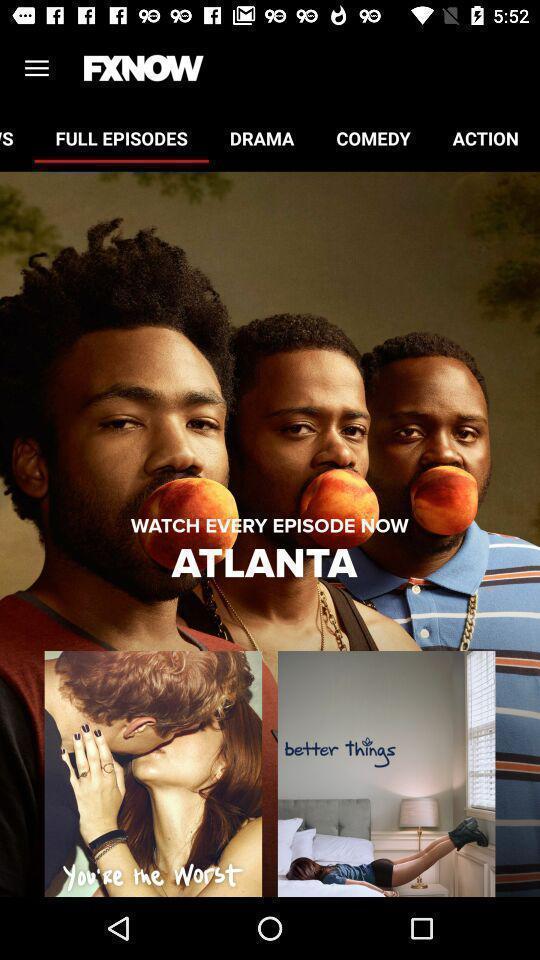Provide a description of this screenshot. Page showing different movies. 